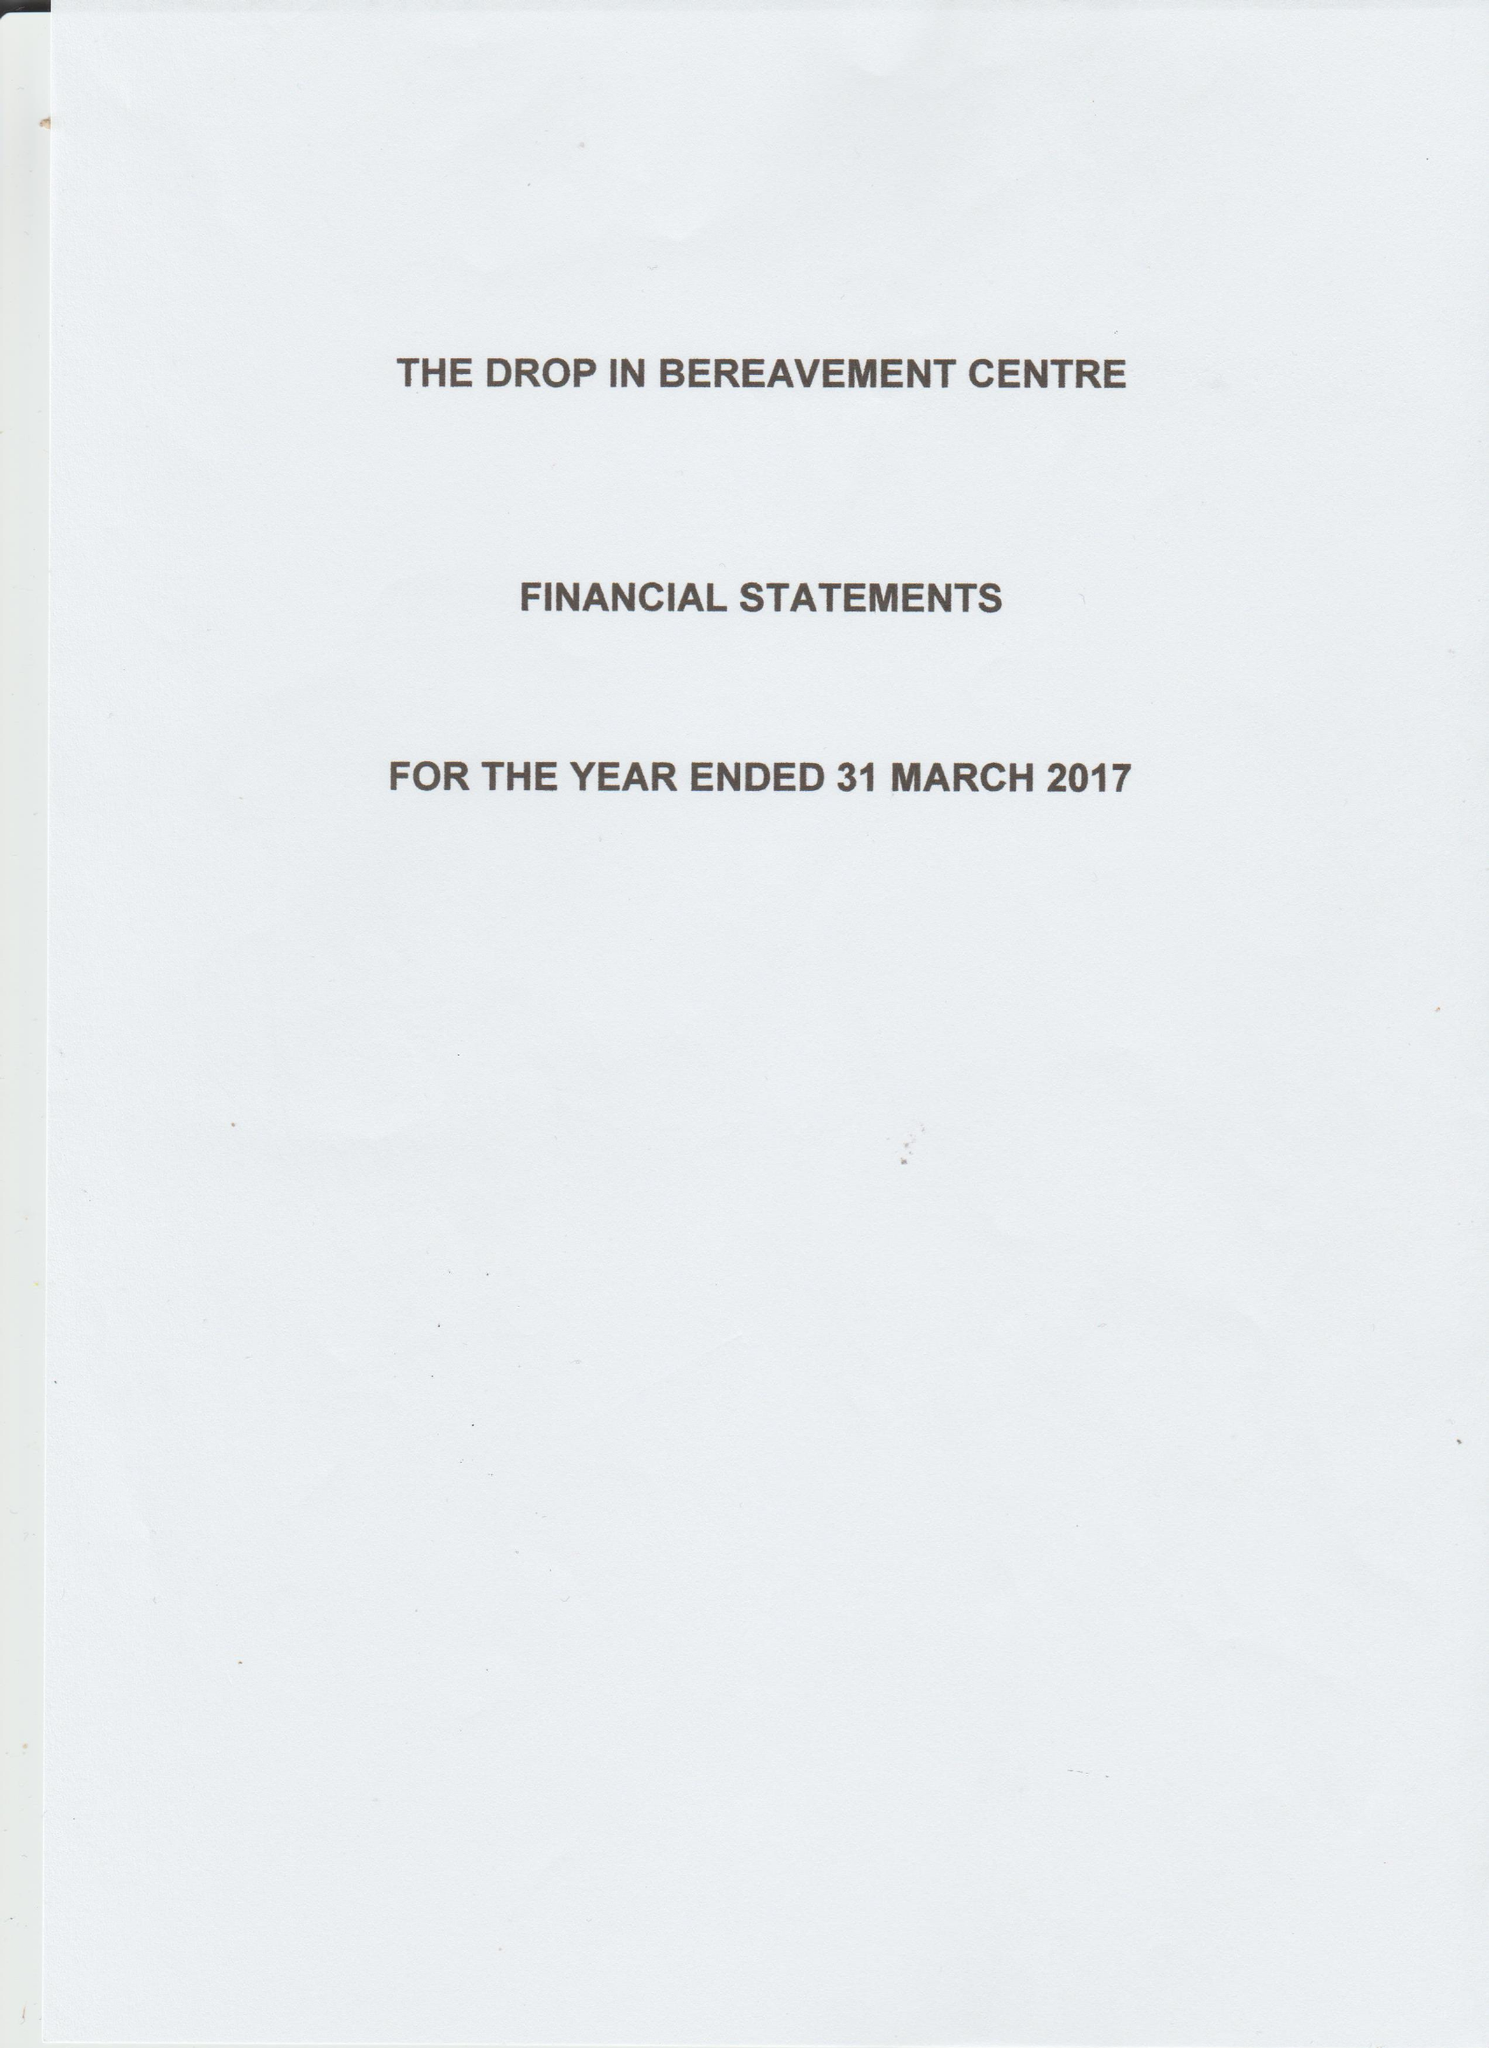What is the value for the address__postcode?
Answer the question using a single word or phrase. E13 0HA 